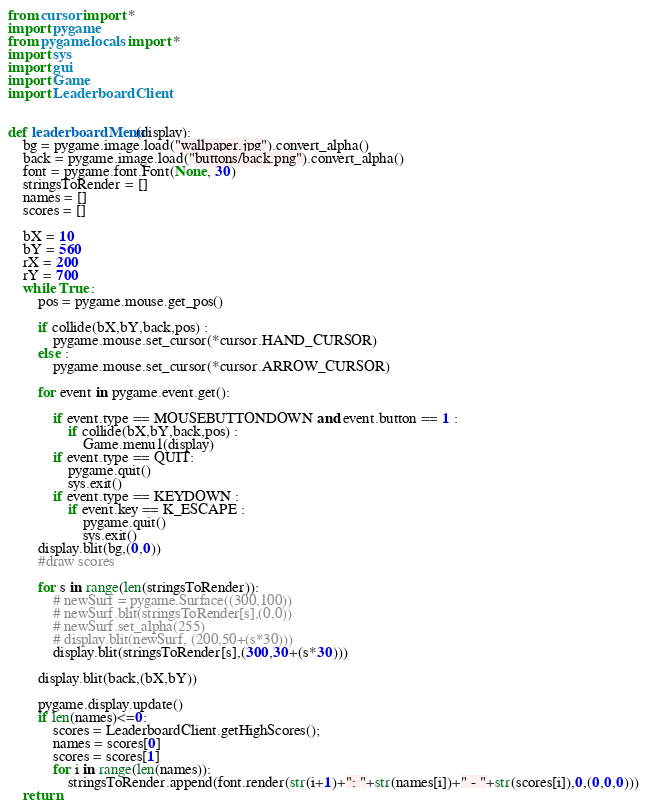<code> <loc_0><loc_0><loc_500><loc_500><_Python_>from cursor import *
import pygame
from pygame.locals import *
import sys
import gui
import Game
import LeaderboardClient


def leaderboardMenu(display):
    bg = pygame.image.load("wallpaper.jpg").convert_alpha()
    back = pygame.image.load("buttons/back.png").convert_alpha()
    font = pygame.font.Font(None, 30)
    stringsToRender = []
    names = []
    scores = []

    bX = 10
    bY = 560
    rX = 200
    rY = 700
    while True :
        pos = pygame.mouse.get_pos()

        if collide(bX,bY,back,pos) :
            pygame.mouse.set_cursor(*cursor.HAND_CURSOR)
        else :
            pygame.mouse.set_cursor(*cursor.ARROW_CURSOR)

        for event in pygame.event.get():

            if event.type == MOUSEBUTTONDOWN and event.button == 1 :
                if collide(bX,bY,back,pos) :
                    Game.menu1(display)
            if event.type == QUIT:
                pygame.quit()
                sys.exit()
            if event.type == KEYDOWN :
                if event.key == K_ESCAPE :
                    pygame.quit()
                    sys.exit()
        display.blit(bg,(0,0))
        #draw scores

        for s in range(len(stringsToRender)):
            # newSurf = pygame.Surface((300,100))
            # newSurf.blit(stringsToRender[s],(0,0))
            # newSurf.set_alpha(255)
            # display.blit(newSurf, (200,50+(s*30)))
            display.blit(stringsToRender[s],(300,30+(s*30)))

        display.blit(back,(bX,bY))

        pygame.display.update()
        if len(names)<=0:
            scores = LeaderboardClient.getHighScores();
            names = scores[0]
            scores = scores[1]
            for i in range(len(names)):
                stringsToRender.append(font.render(str(i+1)+": "+str(names[i])+" - "+str(scores[i]),0,(0,0,0)))
    return
</code> 